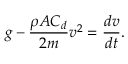<formula> <loc_0><loc_0><loc_500><loc_500>g - { \frac { \rho A C _ { d } } { 2 m } } v ^ { 2 } = { \frac { d v } { d t } } .</formula> 